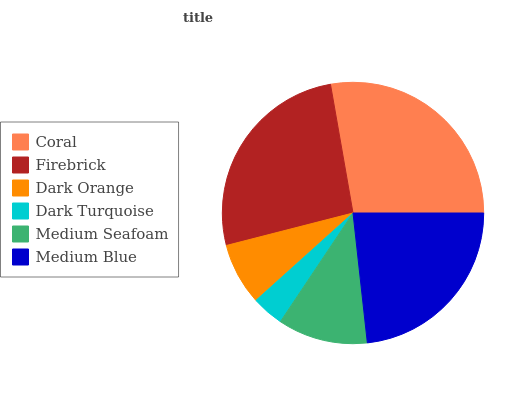Is Dark Turquoise the minimum?
Answer yes or no. Yes. Is Coral the maximum?
Answer yes or no. Yes. Is Firebrick the minimum?
Answer yes or no. No. Is Firebrick the maximum?
Answer yes or no. No. Is Coral greater than Firebrick?
Answer yes or no. Yes. Is Firebrick less than Coral?
Answer yes or no. Yes. Is Firebrick greater than Coral?
Answer yes or no. No. Is Coral less than Firebrick?
Answer yes or no. No. Is Medium Blue the high median?
Answer yes or no. Yes. Is Medium Seafoam the low median?
Answer yes or no. Yes. Is Dark Turquoise the high median?
Answer yes or no. No. Is Dark Orange the low median?
Answer yes or no. No. 